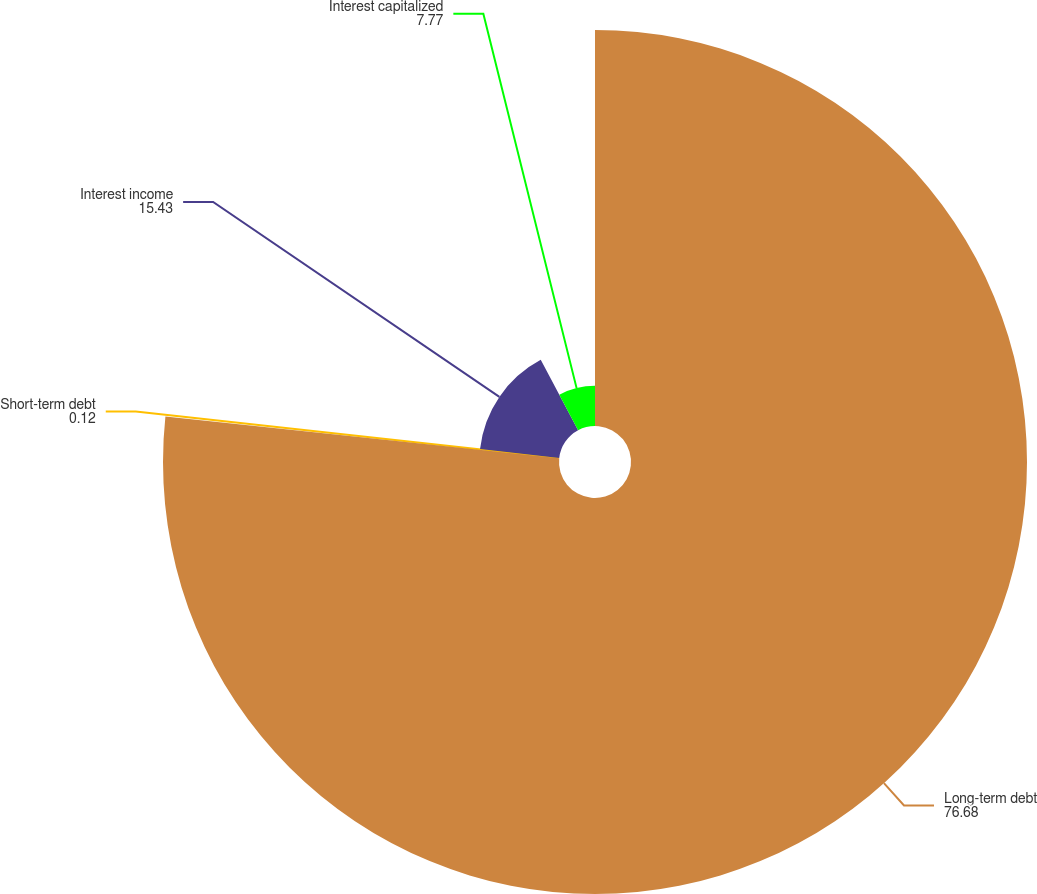Convert chart to OTSL. <chart><loc_0><loc_0><loc_500><loc_500><pie_chart><fcel>Long-term debt<fcel>Short-term debt<fcel>Interest income<fcel>Interest capitalized<nl><fcel>76.68%<fcel>0.12%<fcel>15.43%<fcel>7.77%<nl></chart> 